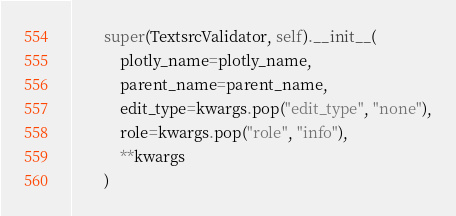<code> <loc_0><loc_0><loc_500><loc_500><_Python_>        super(TextsrcValidator, self).__init__(
            plotly_name=plotly_name,
            parent_name=parent_name,
            edit_type=kwargs.pop("edit_type", "none"),
            role=kwargs.pop("role", "info"),
            **kwargs
        )
</code> 